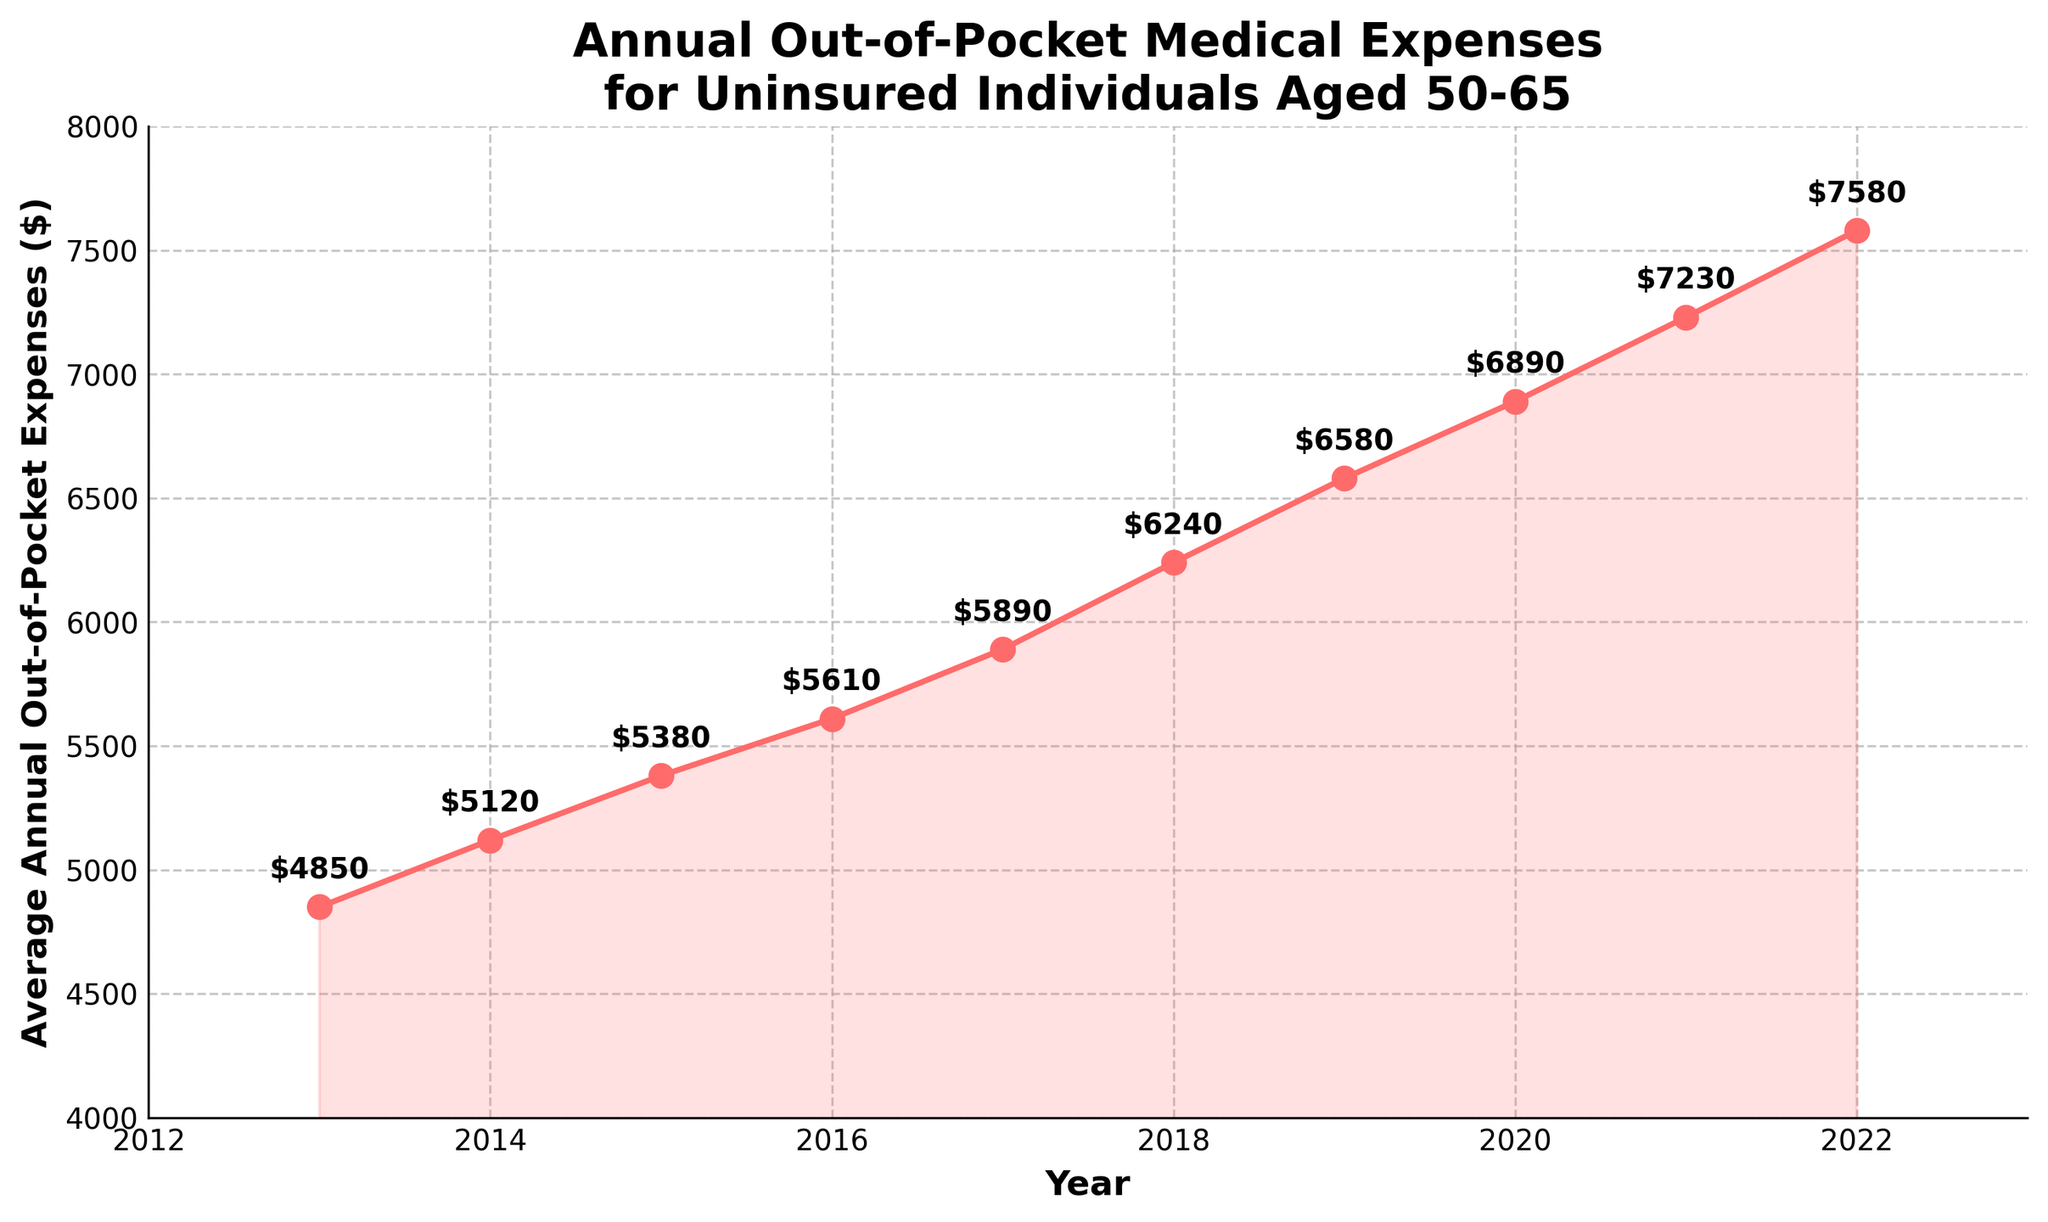What's the highest value of annual out-of-pocket expenses shown in the chart? The chart shows annual out-of-pocket expenses for each year from 2013 to 2022. The highest value is shown at the top end of the line in 2022, which is labeled $7,580.
Answer: $7,580 How much did the average annual out-of-pocket expenses increase from 2013 to 2022? To determine the increase, subtract the 2013 value from the 2022 value. The values are $7,580 (2022) and $4,850 (2013). The increase is $7,580 - $4,850 = $2,730.
Answer: $2,730 Between which two consecutive years did the expenses increase the most? Check the differences between each pair of consecutive years. The increases are as follows: 2013-2014 ($270), 2014-2015 ($260), 2015-2016 ($230), 2016-2017 ($280), 2017-2018 ($350), 2018-2019 ($340), 2019-2020 ($310), 2020-2021 ($340), 2021-2022 ($350). The largest increase occurred between 2017 and 2018 ($350).
Answer: 2017 and 2018 What is the difference between the lowest and highest values of the expenses shown? Identify the lowest and highest values on the chart. The lowest value is in 2013 ($4,850) and the highest value is in 2022 ($7,580). The difference is $7,580 - $4,850 = $2,730.
Answer: $2,730 How do the annual out-of-pocket expenses in 2019 compare to those in 2020? Locate the values for 2019 and 2020 on the chart. The expense for 2019 is $6,580, and for 2020 it is $6,890. The expenses in 2020 are higher than those in 2019 by $6,890 - $6,580 = $310.
Answer: 2020 is higher by $310 How much has the average annual out-of-pocket expense increased each year on average? Determine the total increase from 2013 to 2022, which is $2,730. There are 9 intervals between 10 years (2022-2013). The average annual increase is $2,730 / 9 ≈ $303.33.
Answer: $303.33 Which year had the smallest increase in expenses compared to the previous year? Examine the incremental differences for each pair of consecutive years. The differences are: 2013-2014 ($270), 2014-2015 ($260), 2015-2016 ($230), 2016-2017 ($280), 2017-2018 ($350), 2018-2019 ($340), 2019-2020 ($310), 2020-2021 ($340), 2021-2022 ($350). The smallest increase is between 2015 and 2016 ($230).
Answer: 2015 to 2016 What is the percentage increase in out-of-pocket expenses from 2013 to 2022? Calculate the percentage increase using the formula: ((final value - initial value) / initial value) * 100. The initial value (2013) is $4,850, and the final value (2022) is $7,580. So, ((7,580 - 4,850) / 4,850) * 100 ≈ 56.29%.
Answer: 56.29% What pattern or trend do the annual out-of-pocket expenses show over the decade? The line in the chart shows a consistent upward trend, indicating that the average annual out-of-pocket expenses for uninsured individuals aged 50-65 have increased steadily over the last decade.
Answer: Steady increase 